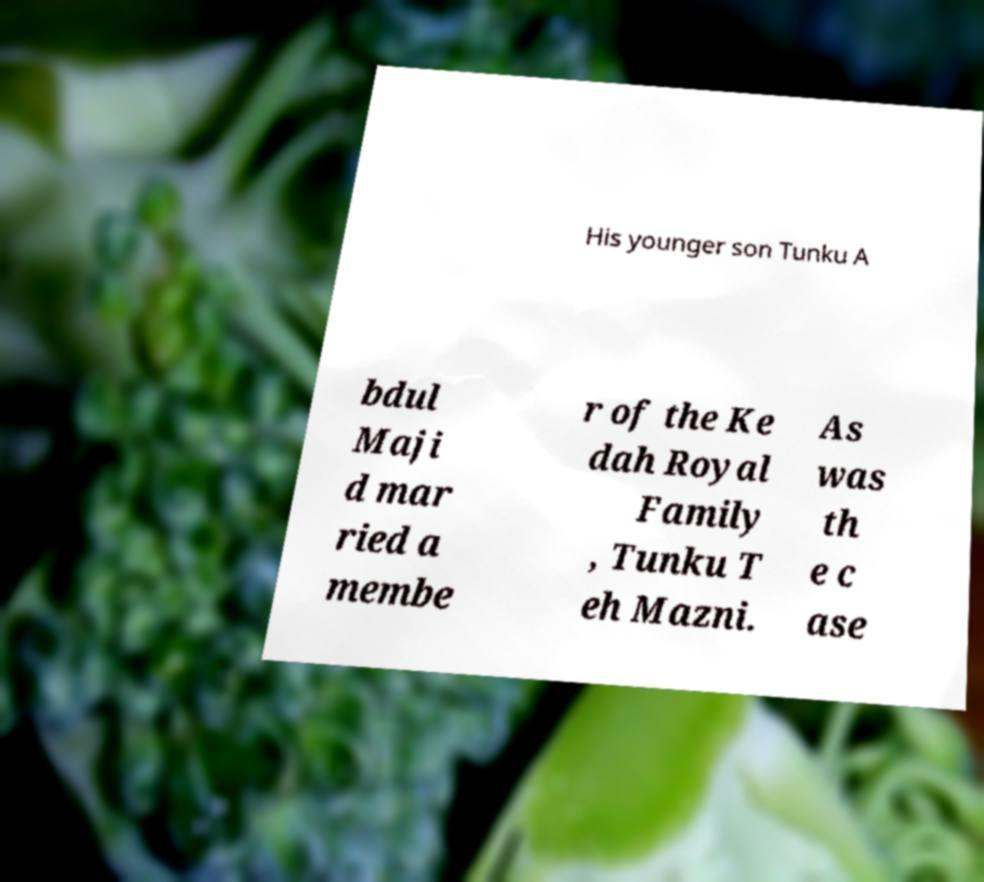What messages or text are displayed in this image? I need them in a readable, typed format. His younger son Tunku A bdul Maji d mar ried a membe r of the Ke dah Royal Family , Tunku T eh Mazni. As was th e c ase 